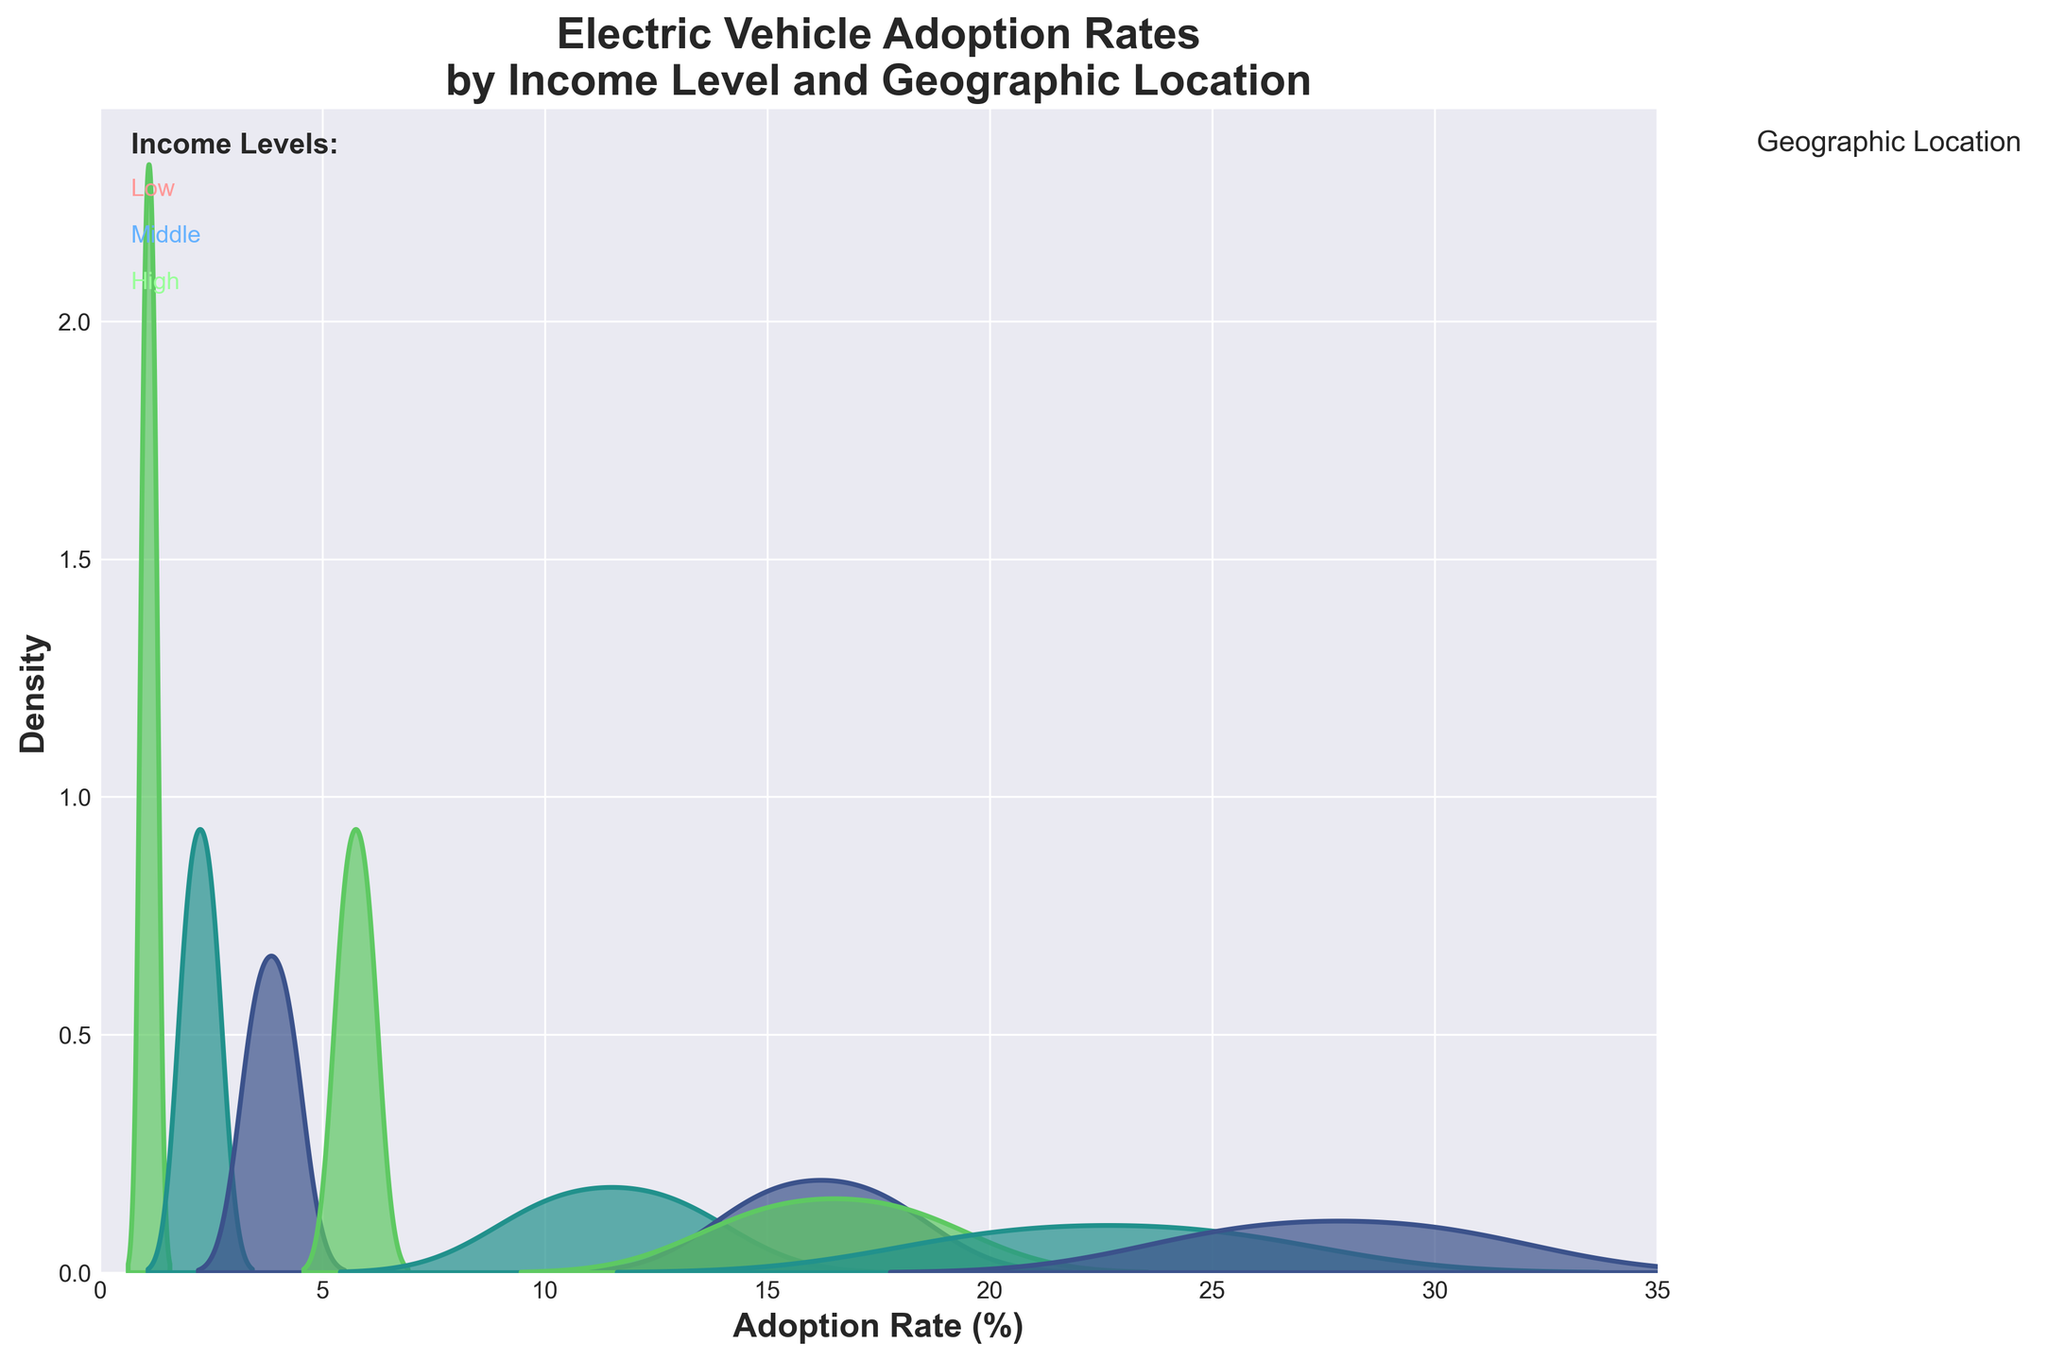What is the title of the figure? The title is displayed at the top of the figure.
Answer: Electric Vehicle Adoption Rates by Income Level and Geographic Location What are the x and y axes labeled? The x-axis label is displayed horizontally at the bottom of the figure, and the y-axis label is displayed vertically on the left side.
Answer: The x-axis is labeled "Adoption Rate (%)" and the y-axis is labeled "Density." Which geographic location generally shows the highest adoption rates? We need to examine the density peaks in the figure across different geographic locations (Urban, Suburban, Rural).
Answer: Urban How do adoption rates for high-income levels compare between Urban and Suburban locations? Look at the density curves for high-income levels and compare the peaks between Urban and Suburban.
Answer: Urban shows higher adoption rates than Suburban What is the range of adoption rates for middle-income levels in Suburban locations? Identify the density curve for middle-income levels in Suburban locations and observe the range where the density is non-zero.
Answer: Approximately 10% to 13% Compare the density peak heights between low-income Urban and Rural locations. Look at the height of the density peaks for low-income levels in Urban and Rural locations.
Answer: Urban peaks are significantly higher than Rural peaks What information is provided in the legend of the figure? The legend provides details about the geographic locations and their color encoding.
Answer: The geographic locations (Urban, Suburban, Rural) and their corresponding colors Which income level shows the most significant spread in adoption rates in Rural locations? Examine the width of the density curves for Rural locations across different income levels.
Answer: High-income level What color represents middle-income levels? Identify the color used for middle-income levels in the text annotations on the figure.
Answer: A shade of blue In Urban locations, how does the adoption rate range differ between low and high-income levels? Compare the ranges of the density curves for Urban locations between low and high-income levels.
Answer: Low-income ranges from roughly 3.5% to 4.2%, while high-income ranges from about 25.7% to 30% 